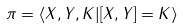Convert formula to latex. <formula><loc_0><loc_0><loc_500><loc_500>\pi = \langle X , Y , K | [ X , Y ] = K \rangle</formula> 